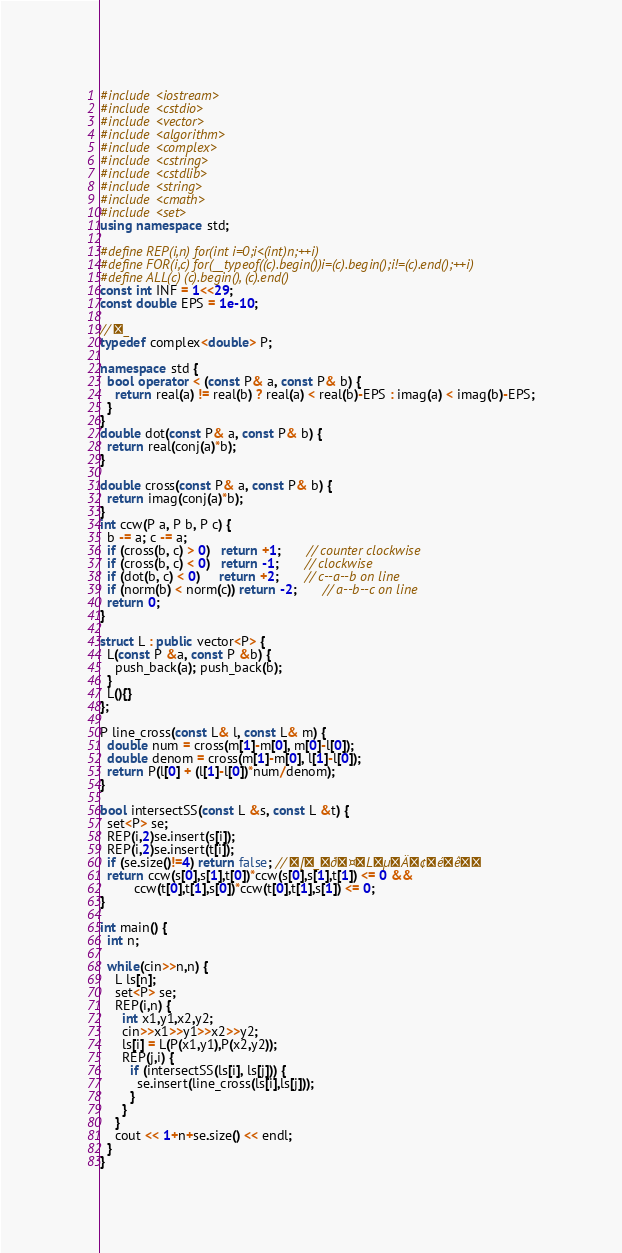<code> <loc_0><loc_0><loc_500><loc_500><_C++_>#include <iostream>
#include <cstdio>
#include <vector>
#include <algorithm>
#include <complex>
#include <cstring>
#include <cstdlib>
#include <string>
#include <cmath>
#include <set>
using namespace std;

#define REP(i,n) for(int i=0;i<(int)n;++i)
#define FOR(i,c) for(__typeof((c).begin())i=(c).begin();i!=(c).end();++i)
#define ALL(c) (c).begin(), (c).end()
const int INF = 1<<29;
const double EPS = 1e-10;

// _
typedef complex<double> P;

namespace std {
  bool operator < (const P& a, const P& b) {
    return real(a) != real(b) ? real(a) < real(b)-EPS : imag(a) < imag(b)-EPS;
  }
}
double dot(const P& a, const P& b) {
  return real(conj(a)*b);
}

double cross(const P& a, const P& b) {
  return imag(conj(a)*b);
}
int ccw(P a, P b, P c) {
  b -= a; c -= a;
  if (cross(b, c) > 0)   return +1;       // counter clockwise
  if (cross(b, c) < 0)   return -1;       // clockwise
  if (dot(b, c) < 0)     return +2;       // c--a--b on line
  if (norm(b) < norm(c)) return -2;       // a--b--c on line
  return 0;
}

struct L : public vector<P> {
  L(const P &a, const P &b) {
    push_back(a); push_back(b);
  }
  L(){}
};

P line_cross(const L& l, const L& m) {
  double num = cross(m[1]-m[0], m[0]-l[0]);
  double denom = cross(m[1]-m[0], l[1]-l[0]);
  return P(l[0] + (l[1]-l[0])*num/denom);
}

bool intersectSS(const L &s, const L &t) {
  set<P> se;
  REP(i,2)se.insert(s[i]);
  REP(i,2)se.insert(t[i]);
  if (se.size()!=4) return false; // [_ð¤LµÄ¢éê
  return ccw(s[0],s[1],t[0])*ccw(s[0],s[1],t[1]) <= 0 &&
         ccw(t[0],t[1],s[0])*ccw(t[0],t[1],s[1]) <= 0;
}

int main() {
  int n;
  
  while(cin>>n,n) {
    L ls[n];
    set<P> se;
    REP(i,n) {
      int x1,y1,x2,y2;
      cin>>x1>>y1>>x2>>y2;
      ls[i] = L(P(x1,y1),P(x2,y2));
      REP(j,i) {
        if (intersectSS(ls[i], ls[j])) {
          se.insert(line_cross(ls[i],ls[j]));
        }
      }
    }
    cout << 1+n+se.size() << endl;
  }
}</code> 